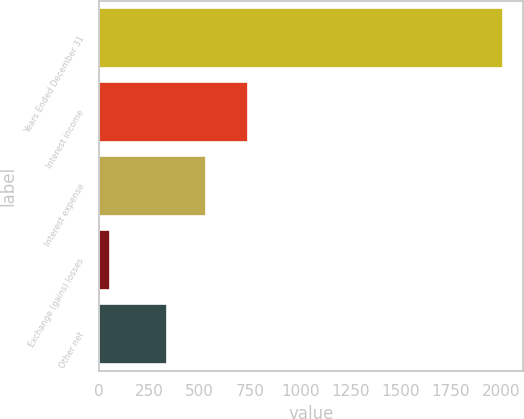Convert chart to OTSL. <chart><loc_0><loc_0><loc_500><loc_500><bar_chart><fcel>Years Ended December 31<fcel>Interest income<fcel>Interest expense<fcel>Exchange (gains) losses<fcel>Other net<nl><fcel>2007<fcel>741.1<fcel>531.17<fcel>54.3<fcel>335.9<nl></chart> 